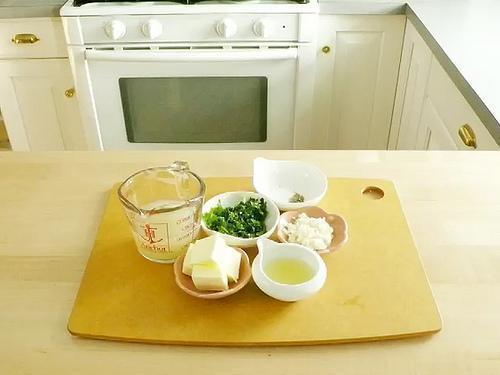Which one of these processes produced the spread here?
Choose the right answer from the provided options to respond to the question.
Options: Eating, food prep, discarding, baking. Food prep. 